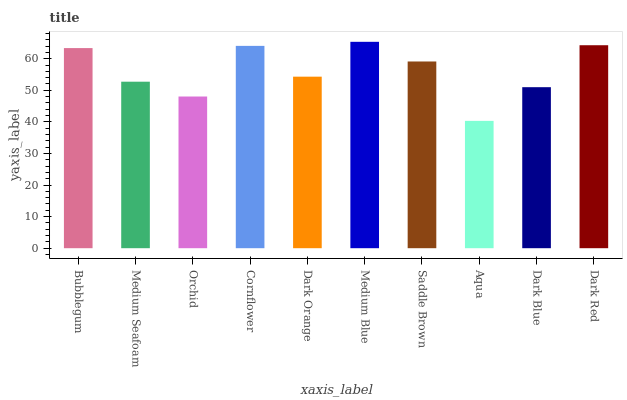Is Aqua the minimum?
Answer yes or no. Yes. Is Medium Blue the maximum?
Answer yes or no. Yes. Is Medium Seafoam the minimum?
Answer yes or no. No. Is Medium Seafoam the maximum?
Answer yes or no. No. Is Bubblegum greater than Medium Seafoam?
Answer yes or no. Yes. Is Medium Seafoam less than Bubblegum?
Answer yes or no. Yes. Is Medium Seafoam greater than Bubblegum?
Answer yes or no. No. Is Bubblegum less than Medium Seafoam?
Answer yes or no. No. Is Saddle Brown the high median?
Answer yes or no. Yes. Is Dark Orange the low median?
Answer yes or no. Yes. Is Dark Red the high median?
Answer yes or no. No. Is Saddle Brown the low median?
Answer yes or no. No. 